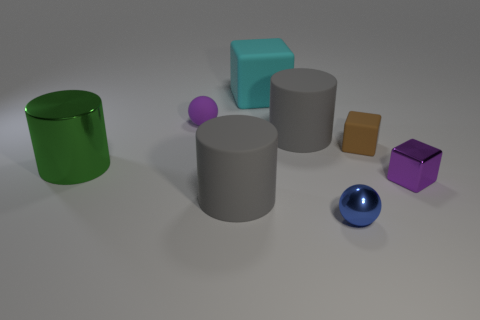How many other objects are there of the same material as the tiny blue thing?
Keep it short and to the point. 2. There is a shiny thing on the left side of the big cyan rubber cube; what shape is it?
Your answer should be very brief. Cylinder. What material is the large gray cylinder that is to the left of the large gray rubber cylinder right of the large cyan block made of?
Keep it short and to the point. Rubber. Is the number of purple balls that are behind the tiny blue thing greater than the number of large yellow rubber spheres?
Give a very brief answer. Yes. What number of other objects are the same color as the big rubber block?
Give a very brief answer. 0. There is a brown thing that is the same size as the purple cube; what shape is it?
Give a very brief answer. Cube. There is a large matte object that is in front of the gray cylinder behind the big shiny cylinder; how many rubber cubes are behind it?
Make the answer very short. 2. What number of matte things are either large cylinders or small spheres?
Provide a succinct answer. 3. The small thing that is both in front of the matte sphere and to the left of the tiny brown rubber thing is what color?
Give a very brief answer. Blue. There is a purple object right of the blue metal thing; does it have the same size as the tiny metallic sphere?
Give a very brief answer. Yes. 